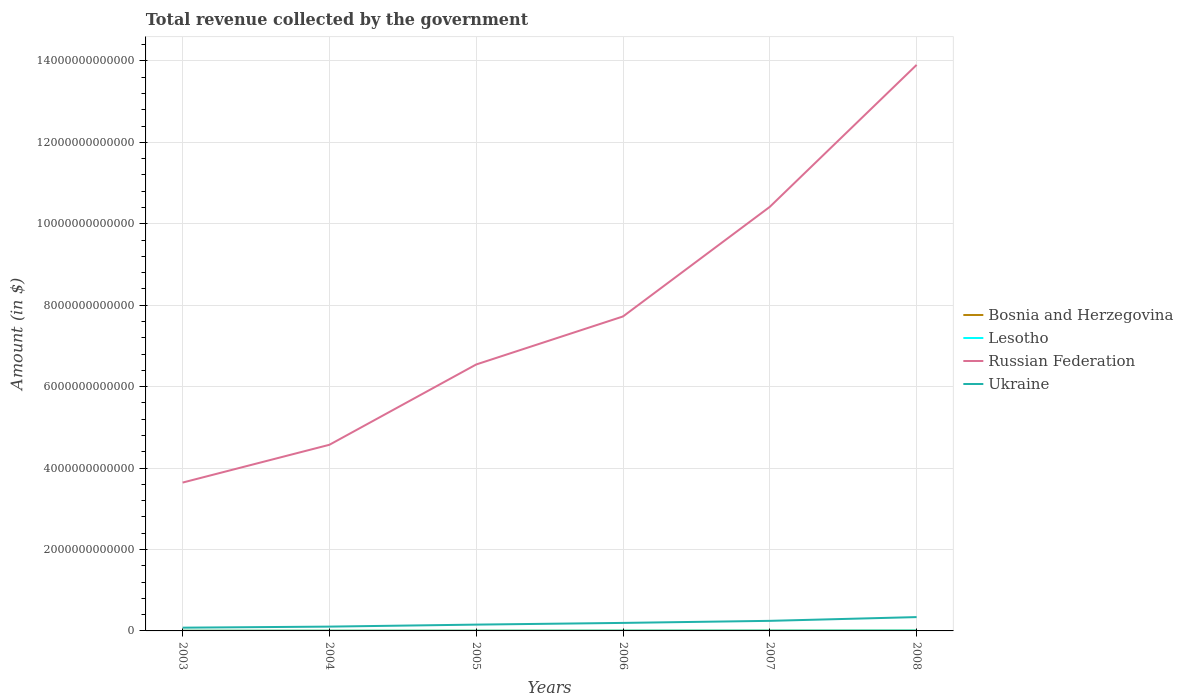How many different coloured lines are there?
Provide a short and direct response. 4. Across all years, what is the maximum total revenue collected by the government in Bosnia and Herzegovina?
Make the answer very short. 5.39e+09. What is the total total revenue collected by the government in Lesotho in the graph?
Give a very brief answer. -3.02e+09. What is the difference between the highest and the second highest total revenue collected by the government in Russian Federation?
Provide a short and direct response. 1.03e+13. What is the difference between the highest and the lowest total revenue collected by the government in Russian Federation?
Provide a succinct answer. 2. How many lines are there?
Your answer should be compact. 4. How many years are there in the graph?
Make the answer very short. 6. What is the difference between two consecutive major ticks on the Y-axis?
Offer a terse response. 2.00e+12. Where does the legend appear in the graph?
Keep it short and to the point. Center right. How many legend labels are there?
Make the answer very short. 4. What is the title of the graph?
Your answer should be compact. Total revenue collected by the government. What is the label or title of the Y-axis?
Provide a succinct answer. Amount (in $). What is the Amount (in $) in Bosnia and Herzegovina in 2003?
Your answer should be very brief. 5.39e+09. What is the Amount (in $) of Lesotho in 2003?
Give a very brief answer. 3.47e+09. What is the Amount (in $) in Russian Federation in 2003?
Give a very brief answer. 3.64e+12. What is the Amount (in $) in Ukraine in 2003?
Provide a short and direct response. 7.99e+1. What is the Amount (in $) in Bosnia and Herzegovina in 2004?
Provide a succinct answer. 5.63e+09. What is the Amount (in $) of Lesotho in 2004?
Make the answer very short. 4.25e+09. What is the Amount (in $) of Russian Federation in 2004?
Offer a terse response. 4.57e+12. What is the Amount (in $) of Ukraine in 2004?
Keep it short and to the point. 1.06e+11. What is the Amount (in $) of Bosnia and Herzegovina in 2005?
Provide a short and direct response. 6.27e+09. What is the Amount (in $) of Lesotho in 2005?
Ensure brevity in your answer.  4.53e+09. What is the Amount (in $) in Russian Federation in 2005?
Offer a terse response. 6.54e+12. What is the Amount (in $) of Ukraine in 2005?
Your response must be concise. 1.55e+11. What is the Amount (in $) of Bosnia and Herzegovina in 2006?
Your answer should be very brief. 7.62e+09. What is the Amount (in $) in Lesotho in 2006?
Your answer should be compact. 6.49e+09. What is the Amount (in $) in Russian Federation in 2006?
Provide a succinct answer. 7.72e+12. What is the Amount (in $) of Ukraine in 2006?
Offer a terse response. 1.97e+11. What is the Amount (in $) of Bosnia and Herzegovina in 2007?
Provide a short and direct response. 8.71e+09. What is the Amount (in $) in Lesotho in 2007?
Provide a short and direct response. 7.13e+09. What is the Amount (in $) of Russian Federation in 2007?
Provide a short and direct response. 1.04e+13. What is the Amount (in $) of Ukraine in 2007?
Offer a terse response. 2.47e+11. What is the Amount (in $) in Bosnia and Herzegovina in 2008?
Your answer should be very brief. 9.67e+09. What is the Amount (in $) of Lesotho in 2008?
Offer a very short reply. 8.76e+09. What is the Amount (in $) of Russian Federation in 2008?
Ensure brevity in your answer.  1.39e+13. What is the Amount (in $) of Ukraine in 2008?
Make the answer very short. 3.40e+11. Across all years, what is the maximum Amount (in $) in Bosnia and Herzegovina?
Give a very brief answer. 9.67e+09. Across all years, what is the maximum Amount (in $) of Lesotho?
Keep it short and to the point. 8.76e+09. Across all years, what is the maximum Amount (in $) of Russian Federation?
Your answer should be very brief. 1.39e+13. Across all years, what is the maximum Amount (in $) of Ukraine?
Your answer should be compact. 3.40e+11. Across all years, what is the minimum Amount (in $) in Bosnia and Herzegovina?
Make the answer very short. 5.39e+09. Across all years, what is the minimum Amount (in $) in Lesotho?
Provide a succinct answer. 3.47e+09. Across all years, what is the minimum Amount (in $) in Russian Federation?
Offer a very short reply. 3.64e+12. Across all years, what is the minimum Amount (in $) in Ukraine?
Provide a succinct answer. 7.99e+1. What is the total Amount (in $) in Bosnia and Herzegovina in the graph?
Your answer should be compact. 4.33e+1. What is the total Amount (in $) of Lesotho in the graph?
Provide a short and direct response. 3.46e+1. What is the total Amount (in $) of Russian Federation in the graph?
Offer a terse response. 4.68e+13. What is the total Amount (in $) in Ukraine in the graph?
Provide a short and direct response. 1.12e+12. What is the difference between the Amount (in $) of Bosnia and Herzegovina in 2003 and that in 2004?
Your answer should be very brief. -2.41e+08. What is the difference between the Amount (in $) of Lesotho in 2003 and that in 2004?
Make the answer very short. -7.84e+08. What is the difference between the Amount (in $) of Russian Federation in 2003 and that in 2004?
Keep it short and to the point. -9.28e+11. What is the difference between the Amount (in $) in Ukraine in 2003 and that in 2004?
Provide a short and direct response. -2.61e+1. What is the difference between the Amount (in $) of Bosnia and Herzegovina in 2003 and that in 2005?
Give a very brief answer. -8.80e+08. What is the difference between the Amount (in $) in Lesotho in 2003 and that in 2005?
Provide a succinct answer. -1.07e+09. What is the difference between the Amount (in $) in Russian Federation in 2003 and that in 2005?
Keep it short and to the point. -2.90e+12. What is the difference between the Amount (in $) in Ukraine in 2003 and that in 2005?
Offer a terse response. -7.51e+1. What is the difference between the Amount (in $) in Bosnia and Herzegovina in 2003 and that in 2006?
Ensure brevity in your answer.  -2.24e+09. What is the difference between the Amount (in $) of Lesotho in 2003 and that in 2006?
Your answer should be compact. -3.02e+09. What is the difference between the Amount (in $) in Russian Federation in 2003 and that in 2006?
Provide a succinct answer. -4.08e+12. What is the difference between the Amount (in $) of Ukraine in 2003 and that in 2006?
Your response must be concise. -1.17e+11. What is the difference between the Amount (in $) in Bosnia and Herzegovina in 2003 and that in 2007?
Keep it short and to the point. -3.32e+09. What is the difference between the Amount (in $) in Lesotho in 2003 and that in 2007?
Offer a terse response. -3.66e+09. What is the difference between the Amount (in $) in Russian Federation in 2003 and that in 2007?
Provide a succinct answer. -6.77e+12. What is the difference between the Amount (in $) in Ukraine in 2003 and that in 2007?
Provide a succinct answer. -1.67e+11. What is the difference between the Amount (in $) in Bosnia and Herzegovina in 2003 and that in 2008?
Provide a succinct answer. -4.28e+09. What is the difference between the Amount (in $) in Lesotho in 2003 and that in 2008?
Ensure brevity in your answer.  -5.29e+09. What is the difference between the Amount (in $) in Russian Federation in 2003 and that in 2008?
Ensure brevity in your answer.  -1.03e+13. What is the difference between the Amount (in $) of Ukraine in 2003 and that in 2008?
Give a very brief answer. -2.60e+11. What is the difference between the Amount (in $) in Bosnia and Herzegovina in 2004 and that in 2005?
Make the answer very short. -6.39e+08. What is the difference between the Amount (in $) of Lesotho in 2004 and that in 2005?
Make the answer very short. -2.81e+08. What is the difference between the Amount (in $) of Russian Federation in 2004 and that in 2005?
Give a very brief answer. -1.97e+12. What is the difference between the Amount (in $) of Ukraine in 2004 and that in 2005?
Keep it short and to the point. -4.90e+1. What is the difference between the Amount (in $) in Bosnia and Herzegovina in 2004 and that in 2006?
Your answer should be compact. -2.00e+09. What is the difference between the Amount (in $) of Lesotho in 2004 and that in 2006?
Your answer should be compact. -2.23e+09. What is the difference between the Amount (in $) of Russian Federation in 2004 and that in 2006?
Your answer should be very brief. -3.15e+12. What is the difference between the Amount (in $) of Ukraine in 2004 and that in 2006?
Keep it short and to the point. -9.10e+1. What is the difference between the Amount (in $) in Bosnia and Herzegovina in 2004 and that in 2007?
Ensure brevity in your answer.  -3.08e+09. What is the difference between the Amount (in $) of Lesotho in 2004 and that in 2007?
Ensure brevity in your answer.  -2.87e+09. What is the difference between the Amount (in $) of Russian Federation in 2004 and that in 2007?
Keep it short and to the point. -5.84e+12. What is the difference between the Amount (in $) in Ukraine in 2004 and that in 2007?
Your answer should be very brief. -1.41e+11. What is the difference between the Amount (in $) of Bosnia and Herzegovina in 2004 and that in 2008?
Offer a very short reply. -4.04e+09. What is the difference between the Amount (in $) in Lesotho in 2004 and that in 2008?
Your answer should be very brief. -4.50e+09. What is the difference between the Amount (in $) in Russian Federation in 2004 and that in 2008?
Your answer should be compact. -9.33e+12. What is the difference between the Amount (in $) in Ukraine in 2004 and that in 2008?
Offer a terse response. -2.34e+11. What is the difference between the Amount (in $) in Bosnia and Herzegovina in 2005 and that in 2006?
Ensure brevity in your answer.  -1.36e+09. What is the difference between the Amount (in $) of Lesotho in 2005 and that in 2006?
Offer a very short reply. -1.95e+09. What is the difference between the Amount (in $) in Russian Federation in 2005 and that in 2006?
Offer a very short reply. -1.18e+12. What is the difference between the Amount (in $) in Ukraine in 2005 and that in 2006?
Provide a succinct answer. -4.20e+1. What is the difference between the Amount (in $) in Bosnia and Herzegovina in 2005 and that in 2007?
Offer a very short reply. -2.44e+09. What is the difference between the Amount (in $) in Lesotho in 2005 and that in 2007?
Your response must be concise. -2.59e+09. What is the difference between the Amount (in $) of Russian Federation in 2005 and that in 2007?
Provide a short and direct response. -3.87e+12. What is the difference between the Amount (in $) of Ukraine in 2005 and that in 2007?
Ensure brevity in your answer.  -9.24e+1. What is the difference between the Amount (in $) of Bosnia and Herzegovina in 2005 and that in 2008?
Provide a short and direct response. -3.40e+09. What is the difference between the Amount (in $) of Lesotho in 2005 and that in 2008?
Give a very brief answer. -4.22e+09. What is the difference between the Amount (in $) of Russian Federation in 2005 and that in 2008?
Offer a very short reply. -7.36e+12. What is the difference between the Amount (in $) in Ukraine in 2005 and that in 2008?
Make the answer very short. -1.85e+11. What is the difference between the Amount (in $) of Bosnia and Herzegovina in 2006 and that in 2007?
Give a very brief answer. -1.09e+09. What is the difference between the Amount (in $) of Lesotho in 2006 and that in 2007?
Your answer should be very brief. -6.38e+08. What is the difference between the Amount (in $) in Russian Federation in 2006 and that in 2007?
Keep it short and to the point. -2.69e+12. What is the difference between the Amount (in $) in Ukraine in 2006 and that in 2007?
Ensure brevity in your answer.  -5.03e+1. What is the difference between the Amount (in $) in Bosnia and Herzegovina in 2006 and that in 2008?
Offer a terse response. -2.04e+09. What is the difference between the Amount (in $) in Lesotho in 2006 and that in 2008?
Ensure brevity in your answer.  -2.27e+09. What is the difference between the Amount (in $) in Russian Federation in 2006 and that in 2008?
Provide a succinct answer. -6.18e+12. What is the difference between the Amount (in $) of Ukraine in 2006 and that in 2008?
Your answer should be very brief. -1.43e+11. What is the difference between the Amount (in $) of Bosnia and Herzegovina in 2007 and that in 2008?
Your answer should be compact. -9.56e+08. What is the difference between the Amount (in $) in Lesotho in 2007 and that in 2008?
Your answer should be compact. -1.63e+09. What is the difference between the Amount (in $) of Russian Federation in 2007 and that in 2008?
Keep it short and to the point. -3.49e+12. What is the difference between the Amount (in $) in Ukraine in 2007 and that in 2008?
Make the answer very short. -9.23e+1. What is the difference between the Amount (in $) of Bosnia and Herzegovina in 2003 and the Amount (in $) of Lesotho in 2004?
Give a very brief answer. 1.13e+09. What is the difference between the Amount (in $) of Bosnia and Herzegovina in 2003 and the Amount (in $) of Russian Federation in 2004?
Offer a very short reply. -4.57e+12. What is the difference between the Amount (in $) in Bosnia and Herzegovina in 2003 and the Amount (in $) in Ukraine in 2004?
Your answer should be compact. -1.01e+11. What is the difference between the Amount (in $) in Lesotho in 2003 and the Amount (in $) in Russian Federation in 2004?
Your response must be concise. -4.57e+12. What is the difference between the Amount (in $) of Lesotho in 2003 and the Amount (in $) of Ukraine in 2004?
Your answer should be very brief. -1.03e+11. What is the difference between the Amount (in $) in Russian Federation in 2003 and the Amount (in $) in Ukraine in 2004?
Give a very brief answer. 3.54e+12. What is the difference between the Amount (in $) of Bosnia and Herzegovina in 2003 and the Amount (in $) of Lesotho in 2005?
Your response must be concise. 8.53e+08. What is the difference between the Amount (in $) of Bosnia and Herzegovina in 2003 and the Amount (in $) of Russian Federation in 2005?
Your answer should be very brief. -6.54e+12. What is the difference between the Amount (in $) in Bosnia and Herzegovina in 2003 and the Amount (in $) in Ukraine in 2005?
Your response must be concise. -1.50e+11. What is the difference between the Amount (in $) of Lesotho in 2003 and the Amount (in $) of Russian Federation in 2005?
Your answer should be very brief. -6.54e+12. What is the difference between the Amount (in $) in Lesotho in 2003 and the Amount (in $) in Ukraine in 2005?
Keep it short and to the point. -1.52e+11. What is the difference between the Amount (in $) in Russian Federation in 2003 and the Amount (in $) in Ukraine in 2005?
Your answer should be compact. 3.49e+12. What is the difference between the Amount (in $) of Bosnia and Herzegovina in 2003 and the Amount (in $) of Lesotho in 2006?
Your answer should be very brief. -1.10e+09. What is the difference between the Amount (in $) in Bosnia and Herzegovina in 2003 and the Amount (in $) in Russian Federation in 2006?
Provide a succinct answer. -7.72e+12. What is the difference between the Amount (in $) of Bosnia and Herzegovina in 2003 and the Amount (in $) of Ukraine in 2006?
Keep it short and to the point. -1.92e+11. What is the difference between the Amount (in $) in Lesotho in 2003 and the Amount (in $) in Russian Federation in 2006?
Keep it short and to the point. -7.72e+12. What is the difference between the Amount (in $) of Lesotho in 2003 and the Amount (in $) of Ukraine in 2006?
Provide a short and direct response. -1.94e+11. What is the difference between the Amount (in $) of Russian Federation in 2003 and the Amount (in $) of Ukraine in 2006?
Offer a very short reply. 3.45e+12. What is the difference between the Amount (in $) in Bosnia and Herzegovina in 2003 and the Amount (in $) in Lesotho in 2007?
Make the answer very short. -1.74e+09. What is the difference between the Amount (in $) in Bosnia and Herzegovina in 2003 and the Amount (in $) in Russian Federation in 2007?
Ensure brevity in your answer.  -1.04e+13. What is the difference between the Amount (in $) in Bosnia and Herzegovina in 2003 and the Amount (in $) in Ukraine in 2007?
Give a very brief answer. -2.42e+11. What is the difference between the Amount (in $) in Lesotho in 2003 and the Amount (in $) in Russian Federation in 2007?
Provide a succinct answer. -1.04e+13. What is the difference between the Amount (in $) of Lesotho in 2003 and the Amount (in $) of Ukraine in 2007?
Your answer should be compact. -2.44e+11. What is the difference between the Amount (in $) of Russian Federation in 2003 and the Amount (in $) of Ukraine in 2007?
Offer a very short reply. 3.40e+12. What is the difference between the Amount (in $) in Bosnia and Herzegovina in 2003 and the Amount (in $) in Lesotho in 2008?
Your answer should be very brief. -3.37e+09. What is the difference between the Amount (in $) in Bosnia and Herzegovina in 2003 and the Amount (in $) in Russian Federation in 2008?
Give a very brief answer. -1.39e+13. What is the difference between the Amount (in $) of Bosnia and Herzegovina in 2003 and the Amount (in $) of Ukraine in 2008?
Ensure brevity in your answer.  -3.34e+11. What is the difference between the Amount (in $) of Lesotho in 2003 and the Amount (in $) of Russian Federation in 2008?
Your answer should be very brief. -1.39e+13. What is the difference between the Amount (in $) of Lesotho in 2003 and the Amount (in $) of Ukraine in 2008?
Your answer should be compact. -3.36e+11. What is the difference between the Amount (in $) in Russian Federation in 2003 and the Amount (in $) in Ukraine in 2008?
Provide a short and direct response. 3.30e+12. What is the difference between the Amount (in $) in Bosnia and Herzegovina in 2004 and the Amount (in $) in Lesotho in 2005?
Your answer should be very brief. 1.09e+09. What is the difference between the Amount (in $) in Bosnia and Herzegovina in 2004 and the Amount (in $) in Russian Federation in 2005?
Your response must be concise. -6.54e+12. What is the difference between the Amount (in $) of Bosnia and Herzegovina in 2004 and the Amount (in $) of Ukraine in 2005?
Your response must be concise. -1.49e+11. What is the difference between the Amount (in $) of Lesotho in 2004 and the Amount (in $) of Russian Federation in 2005?
Provide a succinct answer. -6.54e+12. What is the difference between the Amount (in $) in Lesotho in 2004 and the Amount (in $) in Ukraine in 2005?
Keep it short and to the point. -1.51e+11. What is the difference between the Amount (in $) in Russian Federation in 2004 and the Amount (in $) in Ukraine in 2005?
Provide a short and direct response. 4.42e+12. What is the difference between the Amount (in $) in Bosnia and Herzegovina in 2004 and the Amount (in $) in Lesotho in 2006?
Ensure brevity in your answer.  -8.59e+08. What is the difference between the Amount (in $) of Bosnia and Herzegovina in 2004 and the Amount (in $) of Russian Federation in 2006?
Make the answer very short. -7.72e+12. What is the difference between the Amount (in $) of Bosnia and Herzegovina in 2004 and the Amount (in $) of Ukraine in 2006?
Offer a very short reply. -1.91e+11. What is the difference between the Amount (in $) of Lesotho in 2004 and the Amount (in $) of Russian Federation in 2006?
Your answer should be compact. -7.72e+12. What is the difference between the Amount (in $) in Lesotho in 2004 and the Amount (in $) in Ukraine in 2006?
Your answer should be compact. -1.93e+11. What is the difference between the Amount (in $) of Russian Federation in 2004 and the Amount (in $) of Ukraine in 2006?
Provide a succinct answer. 4.37e+12. What is the difference between the Amount (in $) in Bosnia and Herzegovina in 2004 and the Amount (in $) in Lesotho in 2007?
Give a very brief answer. -1.50e+09. What is the difference between the Amount (in $) in Bosnia and Herzegovina in 2004 and the Amount (in $) in Russian Federation in 2007?
Give a very brief answer. -1.04e+13. What is the difference between the Amount (in $) in Bosnia and Herzegovina in 2004 and the Amount (in $) in Ukraine in 2007?
Your answer should be very brief. -2.42e+11. What is the difference between the Amount (in $) in Lesotho in 2004 and the Amount (in $) in Russian Federation in 2007?
Ensure brevity in your answer.  -1.04e+13. What is the difference between the Amount (in $) in Lesotho in 2004 and the Amount (in $) in Ukraine in 2007?
Your answer should be compact. -2.43e+11. What is the difference between the Amount (in $) of Russian Federation in 2004 and the Amount (in $) of Ukraine in 2007?
Offer a terse response. 4.32e+12. What is the difference between the Amount (in $) in Bosnia and Herzegovina in 2004 and the Amount (in $) in Lesotho in 2008?
Provide a succinct answer. -3.13e+09. What is the difference between the Amount (in $) of Bosnia and Herzegovina in 2004 and the Amount (in $) of Russian Federation in 2008?
Offer a very short reply. -1.39e+13. What is the difference between the Amount (in $) of Bosnia and Herzegovina in 2004 and the Amount (in $) of Ukraine in 2008?
Your response must be concise. -3.34e+11. What is the difference between the Amount (in $) of Lesotho in 2004 and the Amount (in $) of Russian Federation in 2008?
Your answer should be very brief. -1.39e+13. What is the difference between the Amount (in $) of Lesotho in 2004 and the Amount (in $) of Ukraine in 2008?
Your answer should be very brief. -3.35e+11. What is the difference between the Amount (in $) in Russian Federation in 2004 and the Amount (in $) in Ukraine in 2008?
Offer a terse response. 4.23e+12. What is the difference between the Amount (in $) of Bosnia and Herzegovina in 2005 and the Amount (in $) of Lesotho in 2006?
Provide a succinct answer. -2.20e+08. What is the difference between the Amount (in $) in Bosnia and Herzegovina in 2005 and the Amount (in $) in Russian Federation in 2006?
Provide a short and direct response. -7.72e+12. What is the difference between the Amount (in $) of Bosnia and Herzegovina in 2005 and the Amount (in $) of Ukraine in 2006?
Provide a short and direct response. -1.91e+11. What is the difference between the Amount (in $) of Lesotho in 2005 and the Amount (in $) of Russian Federation in 2006?
Make the answer very short. -7.72e+12. What is the difference between the Amount (in $) of Lesotho in 2005 and the Amount (in $) of Ukraine in 2006?
Offer a terse response. -1.92e+11. What is the difference between the Amount (in $) of Russian Federation in 2005 and the Amount (in $) of Ukraine in 2006?
Keep it short and to the point. 6.35e+12. What is the difference between the Amount (in $) of Bosnia and Herzegovina in 2005 and the Amount (in $) of Lesotho in 2007?
Offer a very short reply. -8.58e+08. What is the difference between the Amount (in $) of Bosnia and Herzegovina in 2005 and the Amount (in $) of Russian Federation in 2007?
Your answer should be compact. -1.04e+13. What is the difference between the Amount (in $) of Bosnia and Herzegovina in 2005 and the Amount (in $) of Ukraine in 2007?
Your answer should be very brief. -2.41e+11. What is the difference between the Amount (in $) in Lesotho in 2005 and the Amount (in $) in Russian Federation in 2007?
Offer a terse response. -1.04e+13. What is the difference between the Amount (in $) in Lesotho in 2005 and the Amount (in $) in Ukraine in 2007?
Provide a short and direct response. -2.43e+11. What is the difference between the Amount (in $) of Russian Federation in 2005 and the Amount (in $) of Ukraine in 2007?
Make the answer very short. 6.30e+12. What is the difference between the Amount (in $) in Bosnia and Herzegovina in 2005 and the Amount (in $) in Lesotho in 2008?
Offer a very short reply. -2.49e+09. What is the difference between the Amount (in $) in Bosnia and Herzegovina in 2005 and the Amount (in $) in Russian Federation in 2008?
Provide a succinct answer. -1.39e+13. What is the difference between the Amount (in $) in Bosnia and Herzegovina in 2005 and the Amount (in $) in Ukraine in 2008?
Provide a short and direct response. -3.33e+11. What is the difference between the Amount (in $) in Lesotho in 2005 and the Amount (in $) in Russian Federation in 2008?
Give a very brief answer. -1.39e+13. What is the difference between the Amount (in $) in Lesotho in 2005 and the Amount (in $) in Ukraine in 2008?
Offer a terse response. -3.35e+11. What is the difference between the Amount (in $) in Russian Federation in 2005 and the Amount (in $) in Ukraine in 2008?
Keep it short and to the point. 6.20e+12. What is the difference between the Amount (in $) in Bosnia and Herzegovina in 2006 and the Amount (in $) in Lesotho in 2007?
Your answer should be very brief. 4.99e+08. What is the difference between the Amount (in $) of Bosnia and Herzegovina in 2006 and the Amount (in $) of Russian Federation in 2007?
Ensure brevity in your answer.  -1.04e+13. What is the difference between the Amount (in $) in Bosnia and Herzegovina in 2006 and the Amount (in $) in Ukraine in 2007?
Provide a short and direct response. -2.40e+11. What is the difference between the Amount (in $) of Lesotho in 2006 and the Amount (in $) of Russian Federation in 2007?
Provide a short and direct response. -1.04e+13. What is the difference between the Amount (in $) of Lesotho in 2006 and the Amount (in $) of Ukraine in 2007?
Provide a succinct answer. -2.41e+11. What is the difference between the Amount (in $) of Russian Federation in 2006 and the Amount (in $) of Ukraine in 2007?
Offer a terse response. 7.48e+12. What is the difference between the Amount (in $) in Bosnia and Herzegovina in 2006 and the Amount (in $) in Lesotho in 2008?
Make the answer very short. -1.13e+09. What is the difference between the Amount (in $) in Bosnia and Herzegovina in 2006 and the Amount (in $) in Russian Federation in 2008?
Offer a terse response. -1.39e+13. What is the difference between the Amount (in $) in Bosnia and Herzegovina in 2006 and the Amount (in $) in Ukraine in 2008?
Your response must be concise. -3.32e+11. What is the difference between the Amount (in $) of Lesotho in 2006 and the Amount (in $) of Russian Federation in 2008?
Provide a succinct answer. -1.39e+13. What is the difference between the Amount (in $) of Lesotho in 2006 and the Amount (in $) of Ukraine in 2008?
Your response must be concise. -3.33e+11. What is the difference between the Amount (in $) in Russian Federation in 2006 and the Amount (in $) in Ukraine in 2008?
Your answer should be compact. 7.38e+12. What is the difference between the Amount (in $) of Bosnia and Herzegovina in 2007 and the Amount (in $) of Lesotho in 2008?
Offer a terse response. -4.58e+07. What is the difference between the Amount (in $) of Bosnia and Herzegovina in 2007 and the Amount (in $) of Russian Federation in 2008?
Your answer should be compact. -1.39e+13. What is the difference between the Amount (in $) of Bosnia and Herzegovina in 2007 and the Amount (in $) of Ukraine in 2008?
Offer a terse response. -3.31e+11. What is the difference between the Amount (in $) of Lesotho in 2007 and the Amount (in $) of Russian Federation in 2008?
Your answer should be very brief. -1.39e+13. What is the difference between the Amount (in $) of Lesotho in 2007 and the Amount (in $) of Ukraine in 2008?
Make the answer very short. -3.32e+11. What is the difference between the Amount (in $) in Russian Federation in 2007 and the Amount (in $) in Ukraine in 2008?
Your answer should be very brief. 1.01e+13. What is the average Amount (in $) in Bosnia and Herzegovina per year?
Your answer should be compact. 7.21e+09. What is the average Amount (in $) of Lesotho per year?
Ensure brevity in your answer.  5.77e+09. What is the average Amount (in $) of Russian Federation per year?
Your answer should be compact. 7.80e+12. What is the average Amount (in $) of Ukraine per year?
Provide a short and direct response. 1.87e+11. In the year 2003, what is the difference between the Amount (in $) in Bosnia and Herzegovina and Amount (in $) in Lesotho?
Offer a very short reply. 1.92e+09. In the year 2003, what is the difference between the Amount (in $) of Bosnia and Herzegovina and Amount (in $) of Russian Federation?
Your answer should be very brief. -3.64e+12. In the year 2003, what is the difference between the Amount (in $) of Bosnia and Herzegovina and Amount (in $) of Ukraine?
Your response must be concise. -7.45e+1. In the year 2003, what is the difference between the Amount (in $) of Lesotho and Amount (in $) of Russian Federation?
Keep it short and to the point. -3.64e+12. In the year 2003, what is the difference between the Amount (in $) of Lesotho and Amount (in $) of Ukraine?
Offer a very short reply. -7.64e+1. In the year 2003, what is the difference between the Amount (in $) in Russian Federation and Amount (in $) in Ukraine?
Your response must be concise. 3.56e+12. In the year 2004, what is the difference between the Amount (in $) of Bosnia and Herzegovina and Amount (in $) of Lesotho?
Keep it short and to the point. 1.38e+09. In the year 2004, what is the difference between the Amount (in $) of Bosnia and Herzegovina and Amount (in $) of Russian Federation?
Make the answer very short. -4.57e+12. In the year 2004, what is the difference between the Amount (in $) in Bosnia and Herzegovina and Amount (in $) in Ukraine?
Offer a terse response. -1.00e+11. In the year 2004, what is the difference between the Amount (in $) of Lesotho and Amount (in $) of Russian Federation?
Keep it short and to the point. -4.57e+12. In the year 2004, what is the difference between the Amount (in $) in Lesotho and Amount (in $) in Ukraine?
Keep it short and to the point. -1.02e+11. In the year 2004, what is the difference between the Amount (in $) in Russian Federation and Amount (in $) in Ukraine?
Your answer should be very brief. 4.47e+12. In the year 2005, what is the difference between the Amount (in $) in Bosnia and Herzegovina and Amount (in $) in Lesotho?
Your answer should be very brief. 1.73e+09. In the year 2005, what is the difference between the Amount (in $) in Bosnia and Herzegovina and Amount (in $) in Russian Federation?
Provide a short and direct response. -6.54e+12. In the year 2005, what is the difference between the Amount (in $) in Bosnia and Herzegovina and Amount (in $) in Ukraine?
Give a very brief answer. -1.49e+11. In the year 2005, what is the difference between the Amount (in $) in Lesotho and Amount (in $) in Russian Federation?
Offer a terse response. -6.54e+12. In the year 2005, what is the difference between the Amount (in $) of Lesotho and Amount (in $) of Ukraine?
Offer a very short reply. -1.50e+11. In the year 2005, what is the difference between the Amount (in $) in Russian Federation and Amount (in $) in Ukraine?
Ensure brevity in your answer.  6.39e+12. In the year 2006, what is the difference between the Amount (in $) in Bosnia and Herzegovina and Amount (in $) in Lesotho?
Offer a terse response. 1.14e+09. In the year 2006, what is the difference between the Amount (in $) of Bosnia and Herzegovina and Amount (in $) of Russian Federation?
Your response must be concise. -7.72e+12. In the year 2006, what is the difference between the Amount (in $) of Bosnia and Herzegovina and Amount (in $) of Ukraine?
Offer a terse response. -1.89e+11. In the year 2006, what is the difference between the Amount (in $) in Lesotho and Amount (in $) in Russian Federation?
Offer a very short reply. -7.72e+12. In the year 2006, what is the difference between the Amount (in $) of Lesotho and Amount (in $) of Ukraine?
Your response must be concise. -1.91e+11. In the year 2006, what is the difference between the Amount (in $) in Russian Federation and Amount (in $) in Ukraine?
Your answer should be very brief. 7.53e+12. In the year 2007, what is the difference between the Amount (in $) in Bosnia and Herzegovina and Amount (in $) in Lesotho?
Your answer should be very brief. 1.59e+09. In the year 2007, what is the difference between the Amount (in $) of Bosnia and Herzegovina and Amount (in $) of Russian Federation?
Your answer should be compact. -1.04e+13. In the year 2007, what is the difference between the Amount (in $) of Bosnia and Herzegovina and Amount (in $) of Ukraine?
Provide a short and direct response. -2.39e+11. In the year 2007, what is the difference between the Amount (in $) of Lesotho and Amount (in $) of Russian Federation?
Make the answer very short. -1.04e+13. In the year 2007, what is the difference between the Amount (in $) in Lesotho and Amount (in $) in Ukraine?
Make the answer very short. -2.40e+11. In the year 2007, what is the difference between the Amount (in $) in Russian Federation and Amount (in $) in Ukraine?
Your response must be concise. 1.02e+13. In the year 2008, what is the difference between the Amount (in $) in Bosnia and Herzegovina and Amount (in $) in Lesotho?
Keep it short and to the point. 9.10e+08. In the year 2008, what is the difference between the Amount (in $) of Bosnia and Herzegovina and Amount (in $) of Russian Federation?
Give a very brief answer. -1.39e+13. In the year 2008, what is the difference between the Amount (in $) in Bosnia and Herzegovina and Amount (in $) in Ukraine?
Provide a short and direct response. -3.30e+11. In the year 2008, what is the difference between the Amount (in $) in Lesotho and Amount (in $) in Russian Federation?
Provide a short and direct response. -1.39e+13. In the year 2008, what is the difference between the Amount (in $) of Lesotho and Amount (in $) of Ukraine?
Provide a succinct answer. -3.31e+11. In the year 2008, what is the difference between the Amount (in $) in Russian Federation and Amount (in $) in Ukraine?
Provide a succinct answer. 1.36e+13. What is the ratio of the Amount (in $) in Bosnia and Herzegovina in 2003 to that in 2004?
Your answer should be very brief. 0.96. What is the ratio of the Amount (in $) in Lesotho in 2003 to that in 2004?
Provide a succinct answer. 0.82. What is the ratio of the Amount (in $) in Russian Federation in 2003 to that in 2004?
Provide a succinct answer. 0.8. What is the ratio of the Amount (in $) of Ukraine in 2003 to that in 2004?
Give a very brief answer. 0.75. What is the ratio of the Amount (in $) in Bosnia and Herzegovina in 2003 to that in 2005?
Provide a short and direct response. 0.86. What is the ratio of the Amount (in $) of Lesotho in 2003 to that in 2005?
Your answer should be very brief. 0.77. What is the ratio of the Amount (in $) in Russian Federation in 2003 to that in 2005?
Offer a very short reply. 0.56. What is the ratio of the Amount (in $) in Ukraine in 2003 to that in 2005?
Give a very brief answer. 0.52. What is the ratio of the Amount (in $) of Bosnia and Herzegovina in 2003 to that in 2006?
Provide a succinct answer. 0.71. What is the ratio of the Amount (in $) in Lesotho in 2003 to that in 2006?
Offer a terse response. 0.53. What is the ratio of the Amount (in $) in Russian Federation in 2003 to that in 2006?
Offer a terse response. 0.47. What is the ratio of the Amount (in $) of Ukraine in 2003 to that in 2006?
Your answer should be compact. 0.41. What is the ratio of the Amount (in $) of Bosnia and Herzegovina in 2003 to that in 2007?
Provide a short and direct response. 0.62. What is the ratio of the Amount (in $) in Lesotho in 2003 to that in 2007?
Keep it short and to the point. 0.49. What is the ratio of the Amount (in $) in Russian Federation in 2003 to that in 2007?
Your answer should be very brief. 0.35. What is the ratio of the Amount (in $) of Ukraine in 2003 to that in 2007?
Provide a succinct answer. 0.32. What is the ratio of the Amount (in $) in Bosnia and Herzegovina in 2003 to that in 2008?
Provide a succinct answer. 0.56. What is the ratio of the Amount (in $) of Lesotho in 2003 to that in 2008?
Give a very brief answer. 0.4. What is the ratio of the Amount (in $) of Russian Federation in 2003 to that in 2008?
Make the answer very short. 0.26. What is the ratio of the Amount (in $) in Ukraine in 2003 to that in 2008?
Give a very brief answer. 0.24. What is the ratio of the Amount (in $) in Bosnia and Herzegovina in 2004 to that in 2005?
Your answer should be compact. 0.9. What is the ratio of the Amount (in $) of Lesotho in 2004 to that in 2005?
Ensure brevity in your answer.  0.94. What is the ratio of the Amount (in $) of Russian Federation in 2004 to that in 2005?
Your answer should be compact. 0.7. What is the ratio of the Amount (in $) of Ukraine in 2004 to that in 2005?
Offer a very short reply. 0.68. What is the ratio of the Amount (in $) of Bosnia and Herzegovina in 2004 to that in 2006?
Make the answer very short. 0.74. What is the ratio of the Amount (in $) of Lesotho in 2004 to that in 2006?
Provide a succinct answer. 0.66. What is the ratio of the Amount (in $) of Russian Federation in 2004 to that in 2006?
Your answer should be very brief. 0.59. What is the ratio of the Amount (in $) in Ukraine in 2004 to that in 2006?
Your answer should be very brief. 0.54. What is the ratio of the Amount (in $) in Bosnia and Herzegovina in 2004 to that in 2007?
Your response must be concise. 0.65. What is the ratio of the Amount (in $) in Lesotho in 2004 to that in 2007?
Offer a terse response. 0.6. What is the ratio of the Amount (in $) in Russian Federation in 2004 to that in 2007?
Provide a succinct answer. 0.44. What is the ratio of the Amount (in $) in Ukraine in 2004 to that in 2007?
Offer a terse response. 0.43. What is the ratio of the Amount (in $) of Bosnia and Herzegovina in 2004 to that in 2008?
Provide a short and direct response. 0.58. What is the ratio of the Amount (in $) of Lesotho in 2004 to that in 2008?
Give a very brief answer. 0.49. What is the ratio of the Amount (in $) of Russian Federation in 2004 to that in 2008?
Make the answer very short. 0.33. What is the ratio of the Amount (in $) in Ukraine in 2004 to that in 2008?
Your response must be concise. 0.31. What is the ratio of the Amount (in $) in Bosnia and Herzegovina in 2005 to that in 2006?
Your answer should be compact. 0.82. What is the ratio of the Amount (in $) in Lesotho in 2005 to that in 2006?
Offer a very short reply. 0.7. What is the ratio of the Amount (in $) in Russian Federation in 2005 to that in 2006?
Your response must be concise. 0.85. What is the ratio of the Amount (in $) in Ukraine in 2005 to that in 2006?
Your answer should be very brief. 0.79. What is the ratio of the Amount (in $) in Bosnia and Herzegovina in 2005 to that in 2007?
Offer a very short reply. 0.72. What is the ratio of the Amount (in $) in Lesotho in 2005 to that in 2007?
Offer a terse response. 0.64. What is the ratio of the Amount (in $) of Russian Federation in 2005 to that in 2007?
Give a very brief answer. 0.63. What is the ratio of the Amount (in $) in Ukraine in 2005 to that in 2007?
Ensure brevity in your answer.  0.63. What is the ratio of the Amount (in $) in Bosnia and Herzegovina in 2005 to that in 2008?
Make the answer very short. 0.65. What is the ratio of the Amount (in $) in Lesotho in 2005 to that in 2008?
Keep it short and to the point. 0.52. What is the ratio of the Amount (in $) of Russian Federation in 2005 to that in 2008?
Provide a succinct answer. 0.47. What is the ratio of the Amount (in $) of Ukraine in 2005 to that in 2008?
Offer a very short reply. 0.46. What is the ratio of the Amount (in $) of Bosnia and Herzegovina in 2006 to that in 2007?
Your response must be concise. 0.88. What is the ratio of the Amount (in $) of Lesotho in 2006 to that in 2007?
Offer a terse response. 0.91. What is the ratio of the Amount (in $) of Russian Federation in 2006 to that in 2007?
Make the answer very short. 0.74. What is the ratio of the Amount (in $) of Ukraine in 2006 to that in 2007?
Make the answer very short. 0.8. What is the ratio of the Amount (in $) of Bosnia and Herzegovina in 2006 to that in 2008?
Ensure brevity in your answer.  0.79. What is the ratio of the Amount (in $) in Lesotho in 2006 to that in 2008?
Provide a short and direct response. 0.74. What is the ratio of the Amount (in $) of Russian Federation in 2006 to that in 2008?
Your answer should be compact. 0.56. What is the ratio of the Amount (in $) in Ukraine in 2006 to that in 2008?
Offer a very short reply. 0.58. What is the ratio of the Amount (in $) in Bosnia and Herzegovina in 2007 to that in 2008?
Offer a terse response. 0.9. What is the ratio of the Amount (in $) in Lesotho in 2007 to that in 2008?
Provide a short and direct response. 0.81. What is the ratio of the Amount (in $) in Russian Federation in 2007 to that in 2008?
Give a very brief answer. 0.75. What is the ratio of the Amount (in $) of Ukraine in 2007 to that in 2008?
Your response must be concise. 0.73. What is the difference between the highest and the second highest Amount (in $) in Bosnia and Herzegovina?
Ensure brevity in your answer.  9.56e+08. What is the difference between the highest and the second highest Amount (in $) of Lesotho?
Your answer should be very brief. 1.63e+09. What is the difference between the highest and the second highest Amount (in $) of Russian Federation?
Make the answer very short. 3.49e+12. What is the difference between the highest and the second highest Amount (in $) of Ukraine?
Provide a short and direct response. 9.23e+1. What is the difference between the highest and the lowest Amount (in $) in Bosnia and Herzegovina?
Ensure brevity in your answer.  4.28e+09. What is the difference between the highest and the lowest Amount (in $) in Lesotho?
Offer a very short reply. 5.29e+09. What is the difference between the highest and the lowest Amount (in $) of Russian Federation?
Your answer should be compact. 1.03e+13. What is the difference between the highest and the lowest Amount (in $) in Ukraine?
Provide a short and direct response. 2.60e+11. 